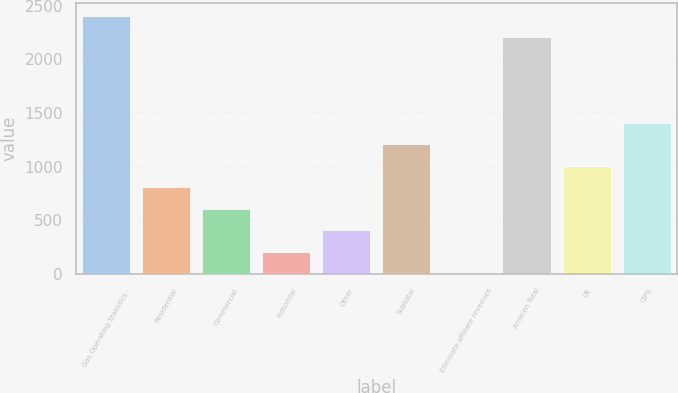Convert chart. <chart><loc_0><loc_0><loc_500><loc_500><bar_chart><fcel>Gas Operating Statistics -<fcel>Residential<fcel>Commercial<fcel>Industrial<fcel>Other<fcel>Subtotal<fcel>Eliminate affiliate revenues<fcel>Ameren Total<fcel>UE<fcel>CIPS<nl><fcel>2407.6<fcel>809.2<fcel>609.4<fcel>209.8<fcel>409.6<fcel>1208.8<fcel>10<fcel>2207.8<fcel>1009<fcel>1408.6<nl></chart> 